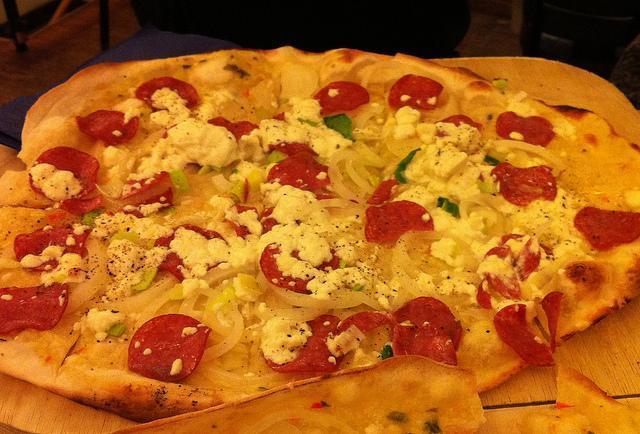How many clocks are shown on the building?
Give a very brief answer. 0. 